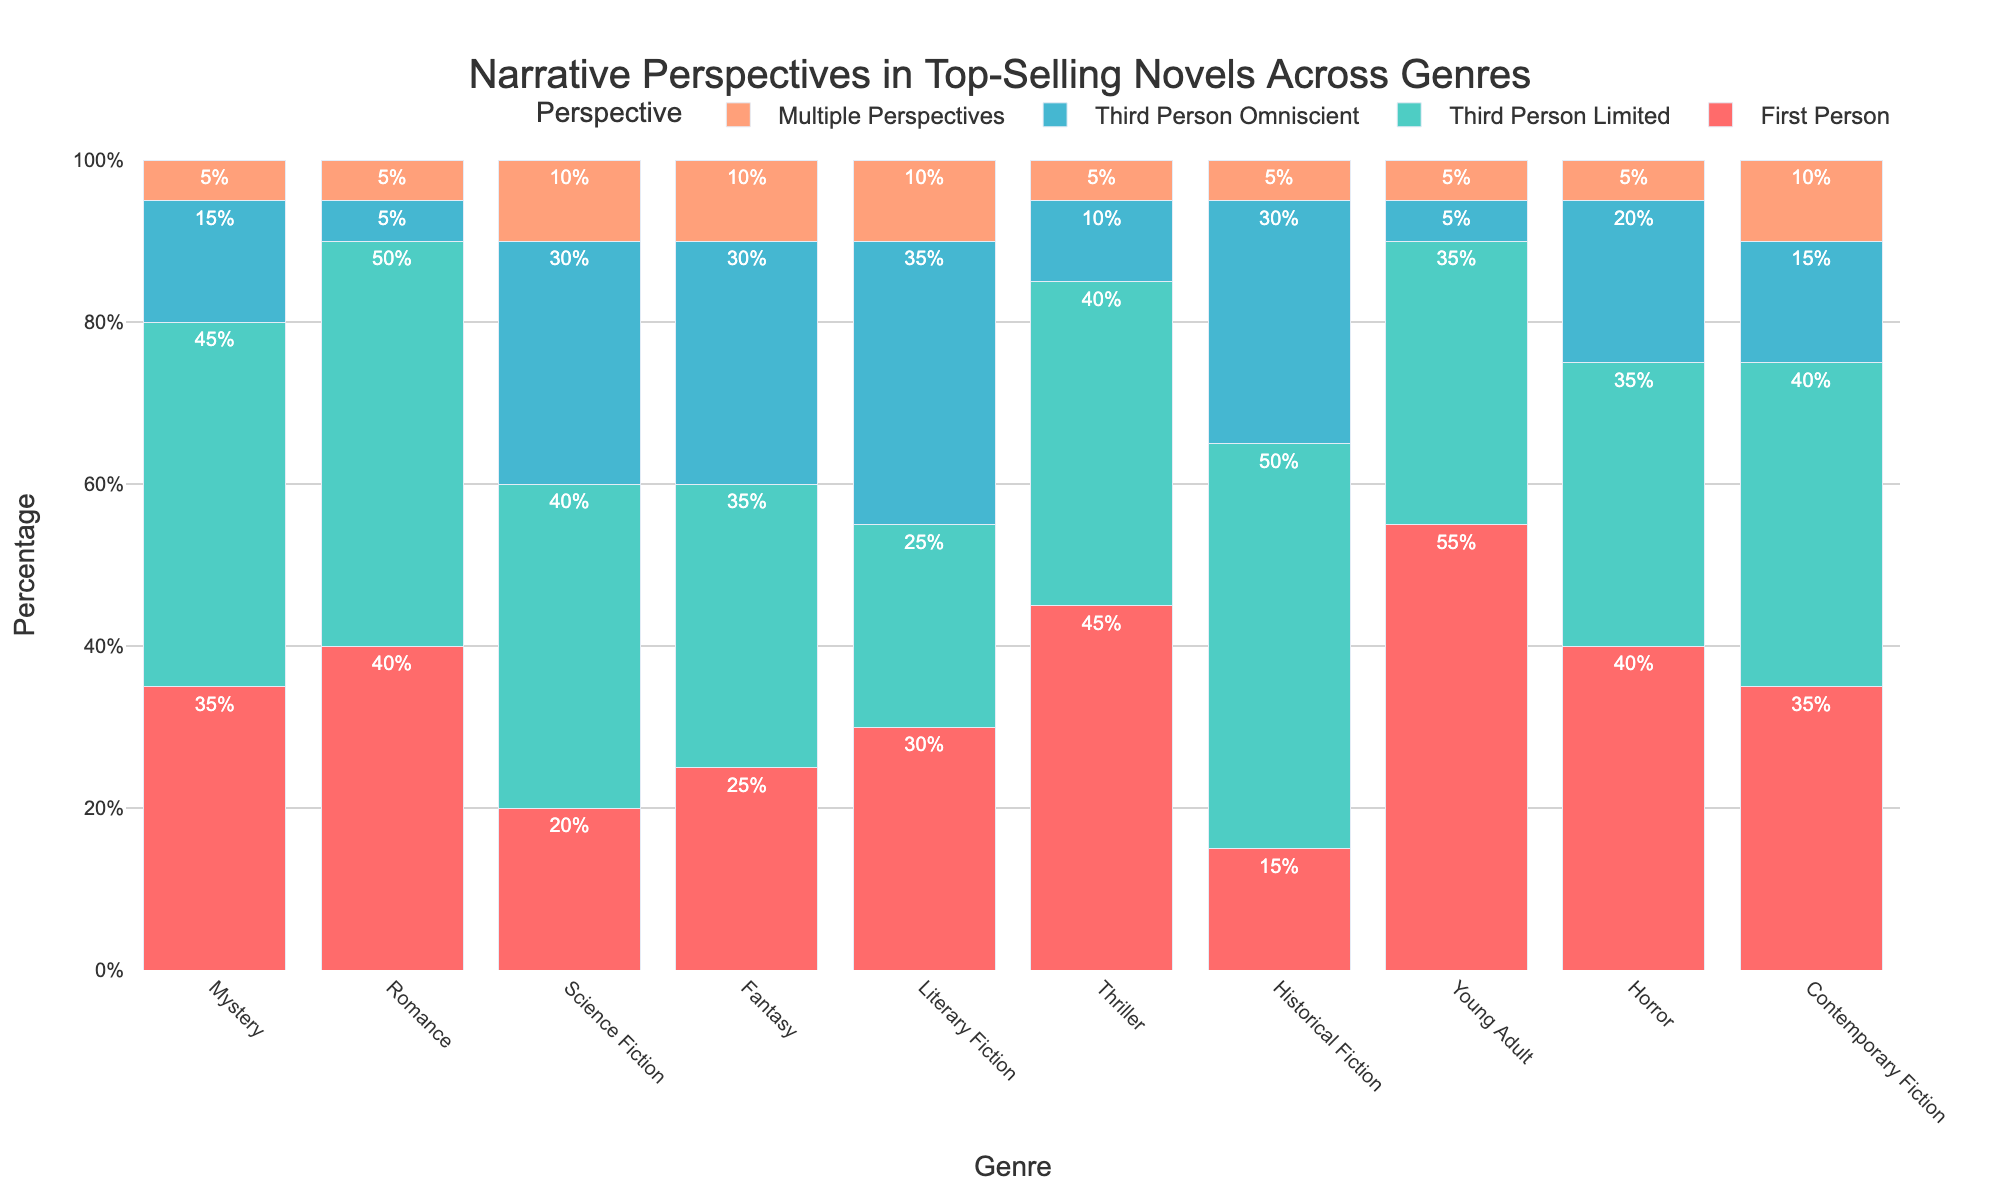What's the most commonly used narrative perspective in Mystery novels? To find out the most commonly used narrative perspective in Mystery novels, check the bar corresponding to the Mystery genre. The tallest bar represents the narrative perspective with the highest percentage. In this case, "Third Person Limited" has the tallest bar for Mystery at 45%.
Answer: Third Person Limited Which genre has the highest percentage of novels written in the First Person perspective? Look for the tallest bar in the First Person perspective section. The genre with the highest bar is Young Adult, showing 55%.
Answer: Young Adult Between Science Fiction and Fantasy genres, which one has a higher percentage of novels using the Third Person Omniscient perspective? Compare the heights of the bars corresponding to the Third Person Omniscient perspective for both Science Fiction and Fantasy genres. Science Fiction has a 30% bar whereas Fantasy also has a 30% bar, indicating they are equal.
Answer: Both have equal percentages What's the combined percentage of First Person and Third Person Omniscient perspectives in Literary Fiction? Add the bars for First Person and Third Person Omniscient perspectives in the Literary Fiction genre. First Person is 30% and Third Person Omniscient is 35%. So the combined percentage is 30% + 35% = 65%.
Answer: 65% Which genre has the least diversity in narrative perspectives used, i.e., highest percentage of a single perspective? Identify the genre where one narrative perspective dominates more than others. Young Adult has 55% for First Person, which is the highest single perspective percentage in any genre.
Answer: Young Adult How does the usage of Multiple Perspectives in Contemporary Fiction compare to Historical Fiction? Compare the bar heights of the Multiple Perspectives in Contemporary Fiction and Historical Fiction. Both genres show a 5% usage of Multiple Perspectives.
Answer: Equal What is the total percentage of Third Person Limited narratives across Mystery and Thriller genres? Add the Third Person Limited percentages for Mystery (45%) and Thriller (40%). Thus, the combined total is 45% + 40% = 85%.
Answer: 85% Which genre uses the Third Person Limited narrative perspective the least? Look for the shortest bar in Third Person Limited across all genres. Literary Fiction has the shortest bar of 25%.
Answer: Literary Fiction Is the usage of First Person perspective in Romance higher than in Horror? Compare the heights of the First Person perspective bars for Romance and Horror. Romance is 40% and Horror is also 40%, indicating they are equal.
Answer: Equal What’s the difference in percentage between the First Person and Multiple Perspectives in Science Fiction? Subtract the percentage of Multiple Perspectives from the First Person in Science Fiction. First Person is 20% and Multiple Perspectives is 10%, so the difference is 20% - 10% = 10%.
Answer: 10% 